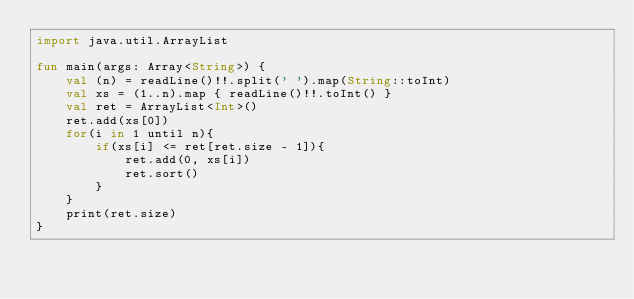<code> <loc_0><loc_0><loc_500><loc_500><_Kotlin_>import java.util.ArrayList

fun main(args: Array<String>) {
    val (n) = readLine()!!.split(' ').map(String::toInt)
    val xs = (1..n).map { readLine()!!.toInt() }
    val ret = ArrayList<Int>()
    ret.add(xs[0])
    for(i in 1 until n){
        if(xs[i] <= ret[ret.size - 1]){
            ret.add(0, xs[i])
            ret.sort()
        }
    }
    print(ret.size)
}</code> 